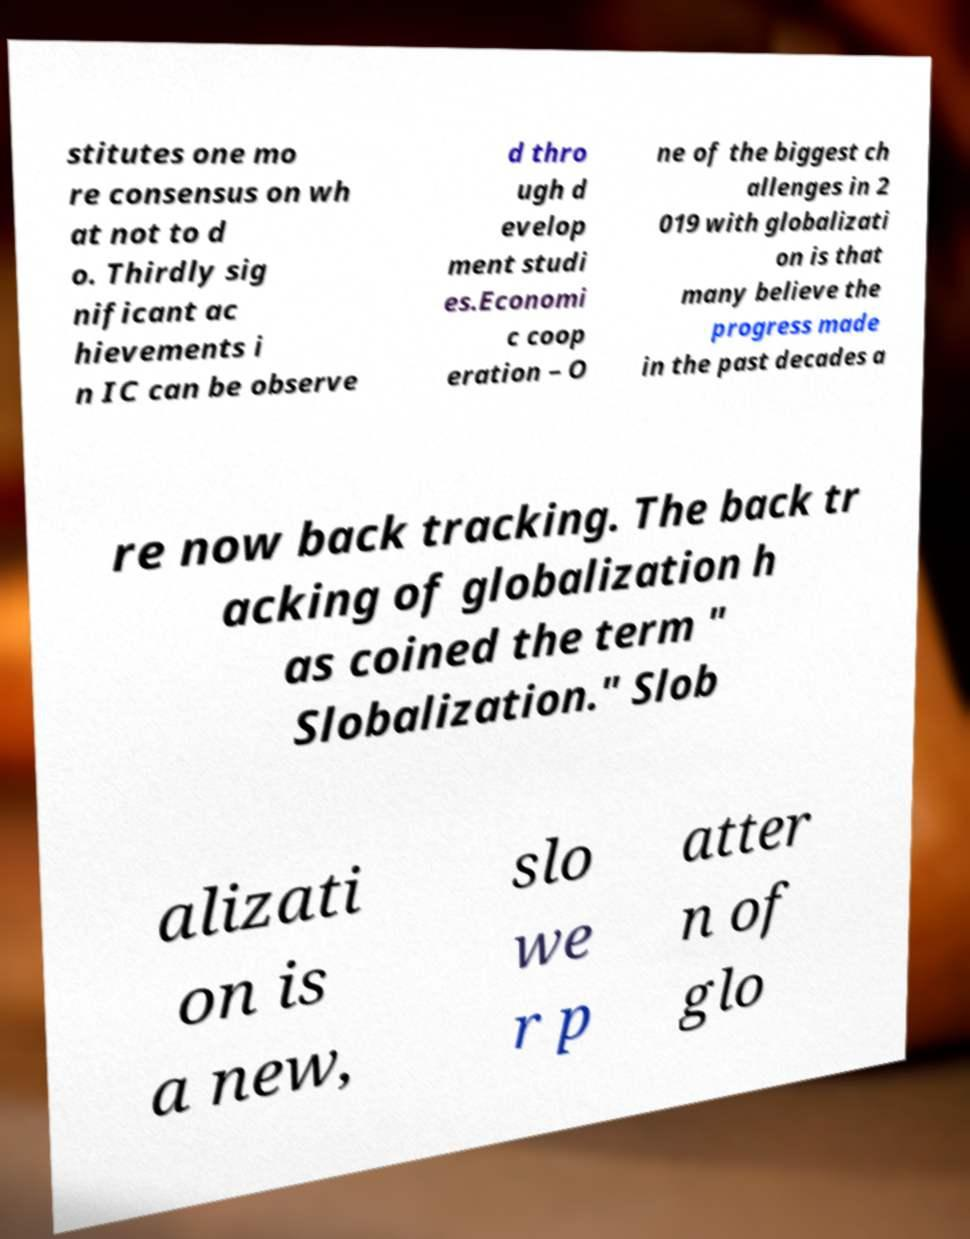Could you assist in decoding the text presented in this image and type it out clearly? stitutes one mo re consensus on wh at not to d o. Thirdly sig nificant ac hievements i n IC can be observe d thro ugh d evelop ment studi es.Economi c coop eration – O ne of the biggest ch allenges in 2 019 with globalizati on is that many believe the progress made in the past decades a re now back tracking. The back tr acking of globalization h as coined the term " Slobalization." Slob alizati on is a new, slo we r p atter n of glo 